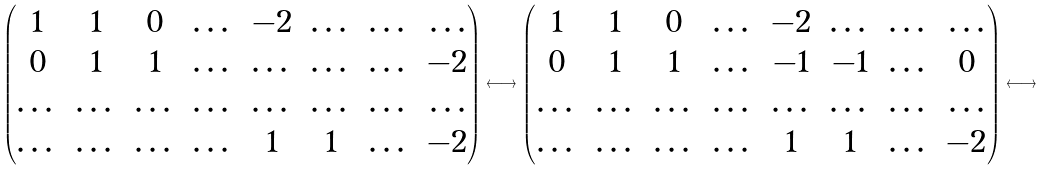<formula> <loc_0><loc_0><loc_500><loc_500>\left ( \begin{matrix} 1 & 1 & 0 & \dots & - 2 & \dots & \dots & \dots \\ 0 & 1 & 1 & \dots & \dots & \dots & \dots & - 2 \\ \dots & \dots & \dots & \dots & \dots & \dots & \dots & \dots \\ \dots & \dots & \dots & \dots & 1 & 1 & \dots & - 2 \end{matrix} \right ) \longleftrightarrow \left ( \begin{matrix} 1 & 1 & 0 & \dots & - 2 & \dots & \dots & \dots \\ 0 & 1 & 1 & \dots & - 1 & - 1 & \dots & 0 \\ \dots & \dots & \dots & \dots & \dots & \dots & \dots & \dots \\ \dots & \dots & \dots & \dots & 1 & 1 & \dots & - 2 \end{matrix} \right ) \longleftrightarrow</formula> 